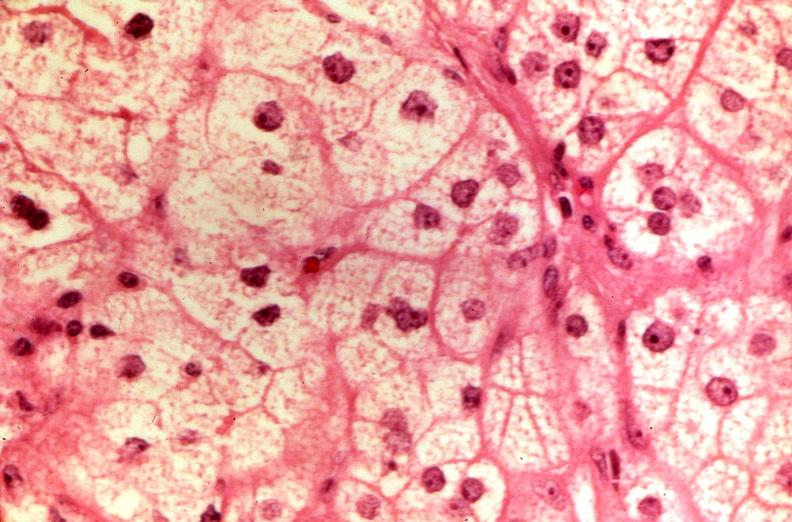s natural color present?
Answer the question using a single word or phrase. No 